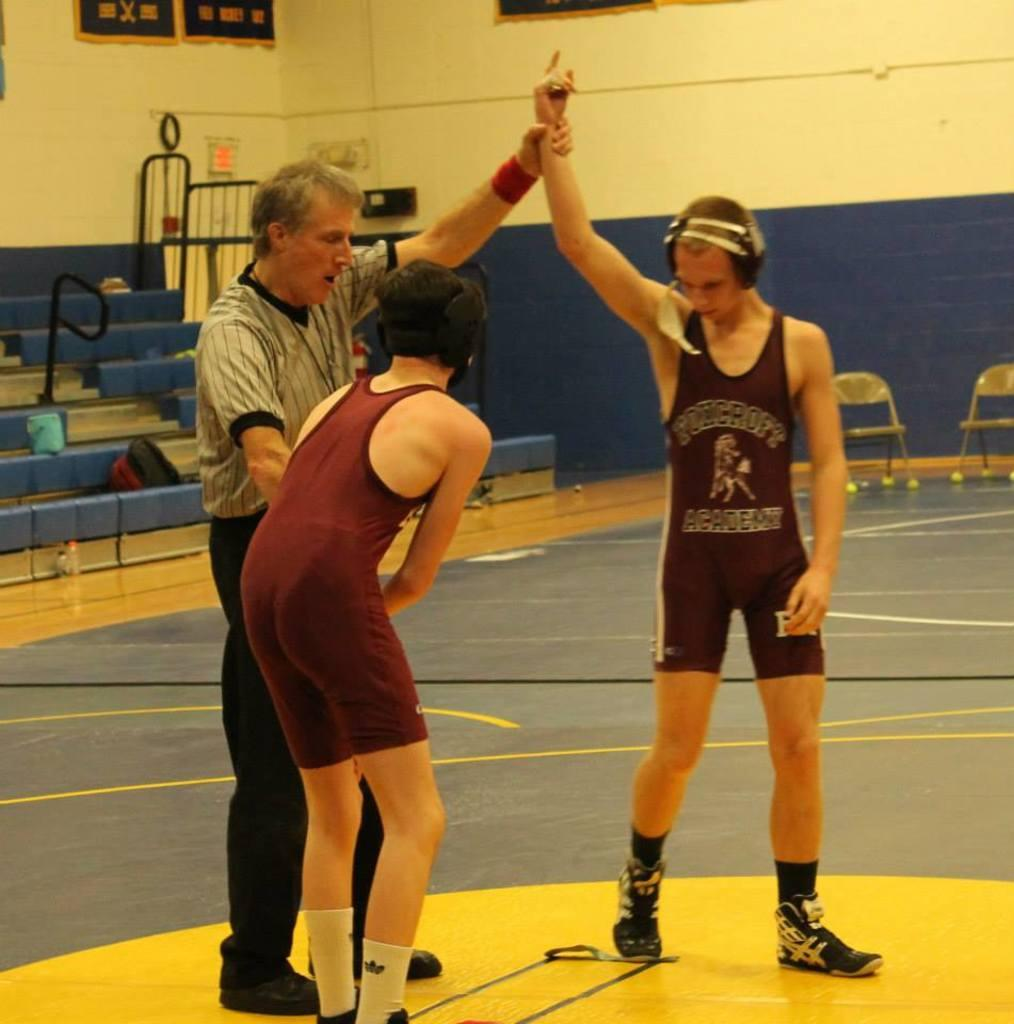<image>
Share a concise interpretation of the image provided. some wrestlers with one having the word academy on their shirt 